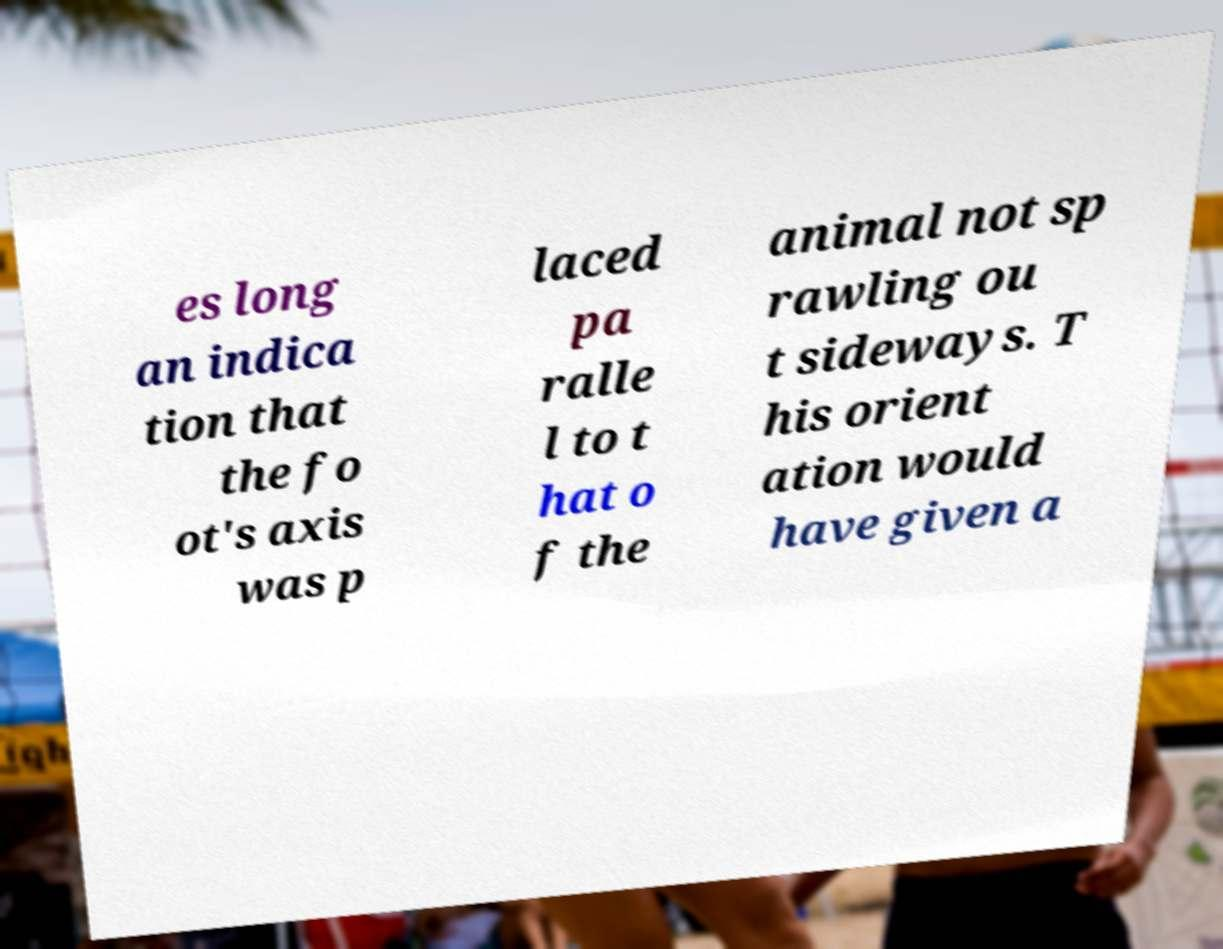Can you read and provide the text displayed in the image?This photo seems to have some interesting text. Can you extract and type it out for me? es long an indica tion that the fo ot's axis was p laced pa ralle l to t hat o f the animal not sp rawling ou t sideways. T his orient ation would have given a 